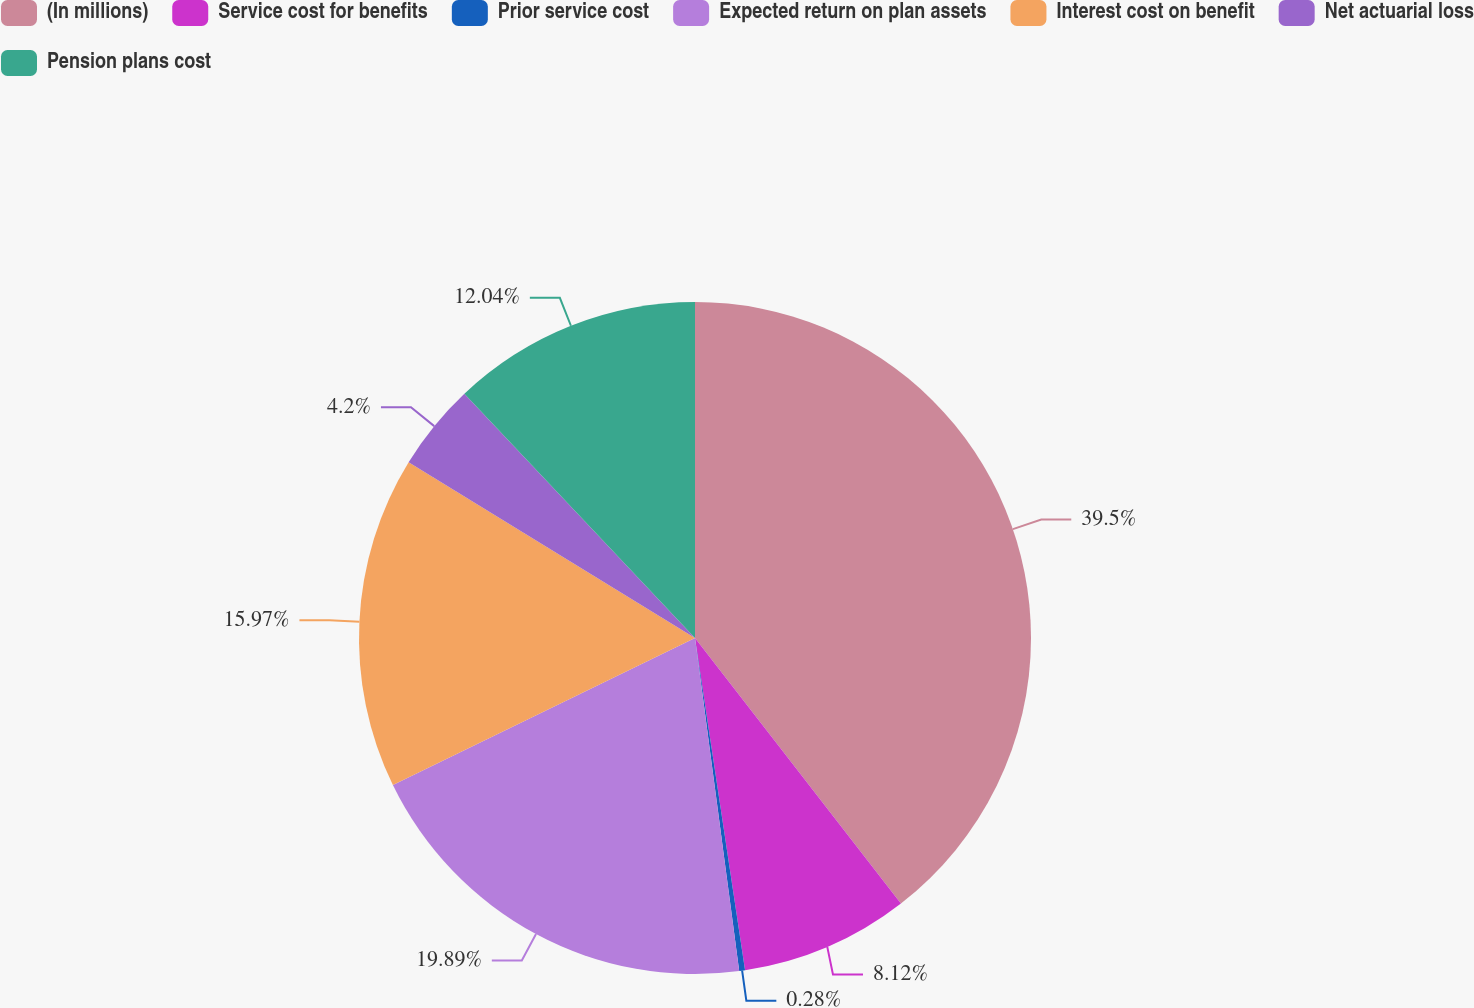Convert chart. <chart><loc_0><loc_0><loc_500><loc_500><pie_chart><fcel>(In millions)<fcel>Service cost for benefits<fcel>Prior service cost<fcel>Expected return on plan assets<fcel>Interest cost on benefit<fcel>Net actuarial loss<fcel>Pension plans cost<nl><fcel>39.5%<fcel>8.12%<fcel>0.28%<fcel>19.89%<fcel>15.97%<fcel>4.2%<fcel>12.04%<nl></chart> 